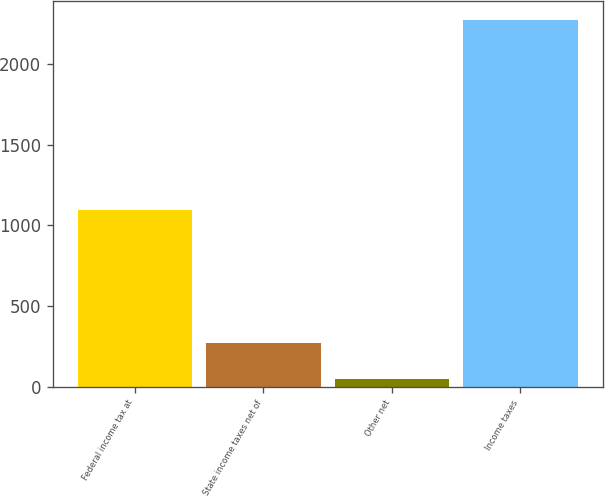Convert chart. <chart><loc_0><loc_0><loc_500><loc_500><bar_chart><fcel>Federal income tax at<fcel>State income taxes net of<fcel>Other net<fcel>Income taxes<nl><fcel>1095<fcel>273.5<fcel>51<fcel>2276<nl></chart> 